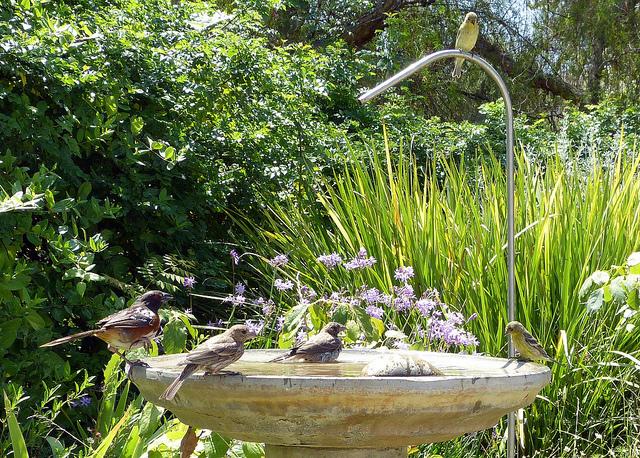What are the birds doing?
Be succinct. Bathing. How many birds are there?
Answer briefly. 5. Are those real birds?
Quick response, please. Yes. 